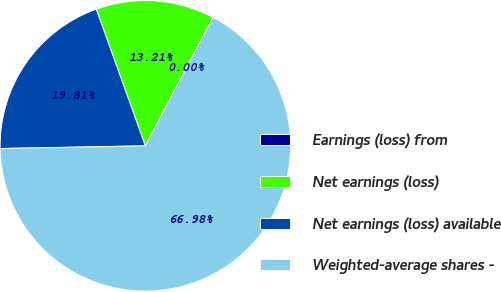<chart> <loc_0><loc_0><loc_500><loc_500><pie_chart><fcel>Earnings (loss) from<fcel>Net earnings (loss)<fcel>Net earnings (loss) available<fcel>Weighted-average shares -<nl><fcel>0.0%<fcel>13.21%<fcel>19.81%<fcel>66.99%<nl></chart> 